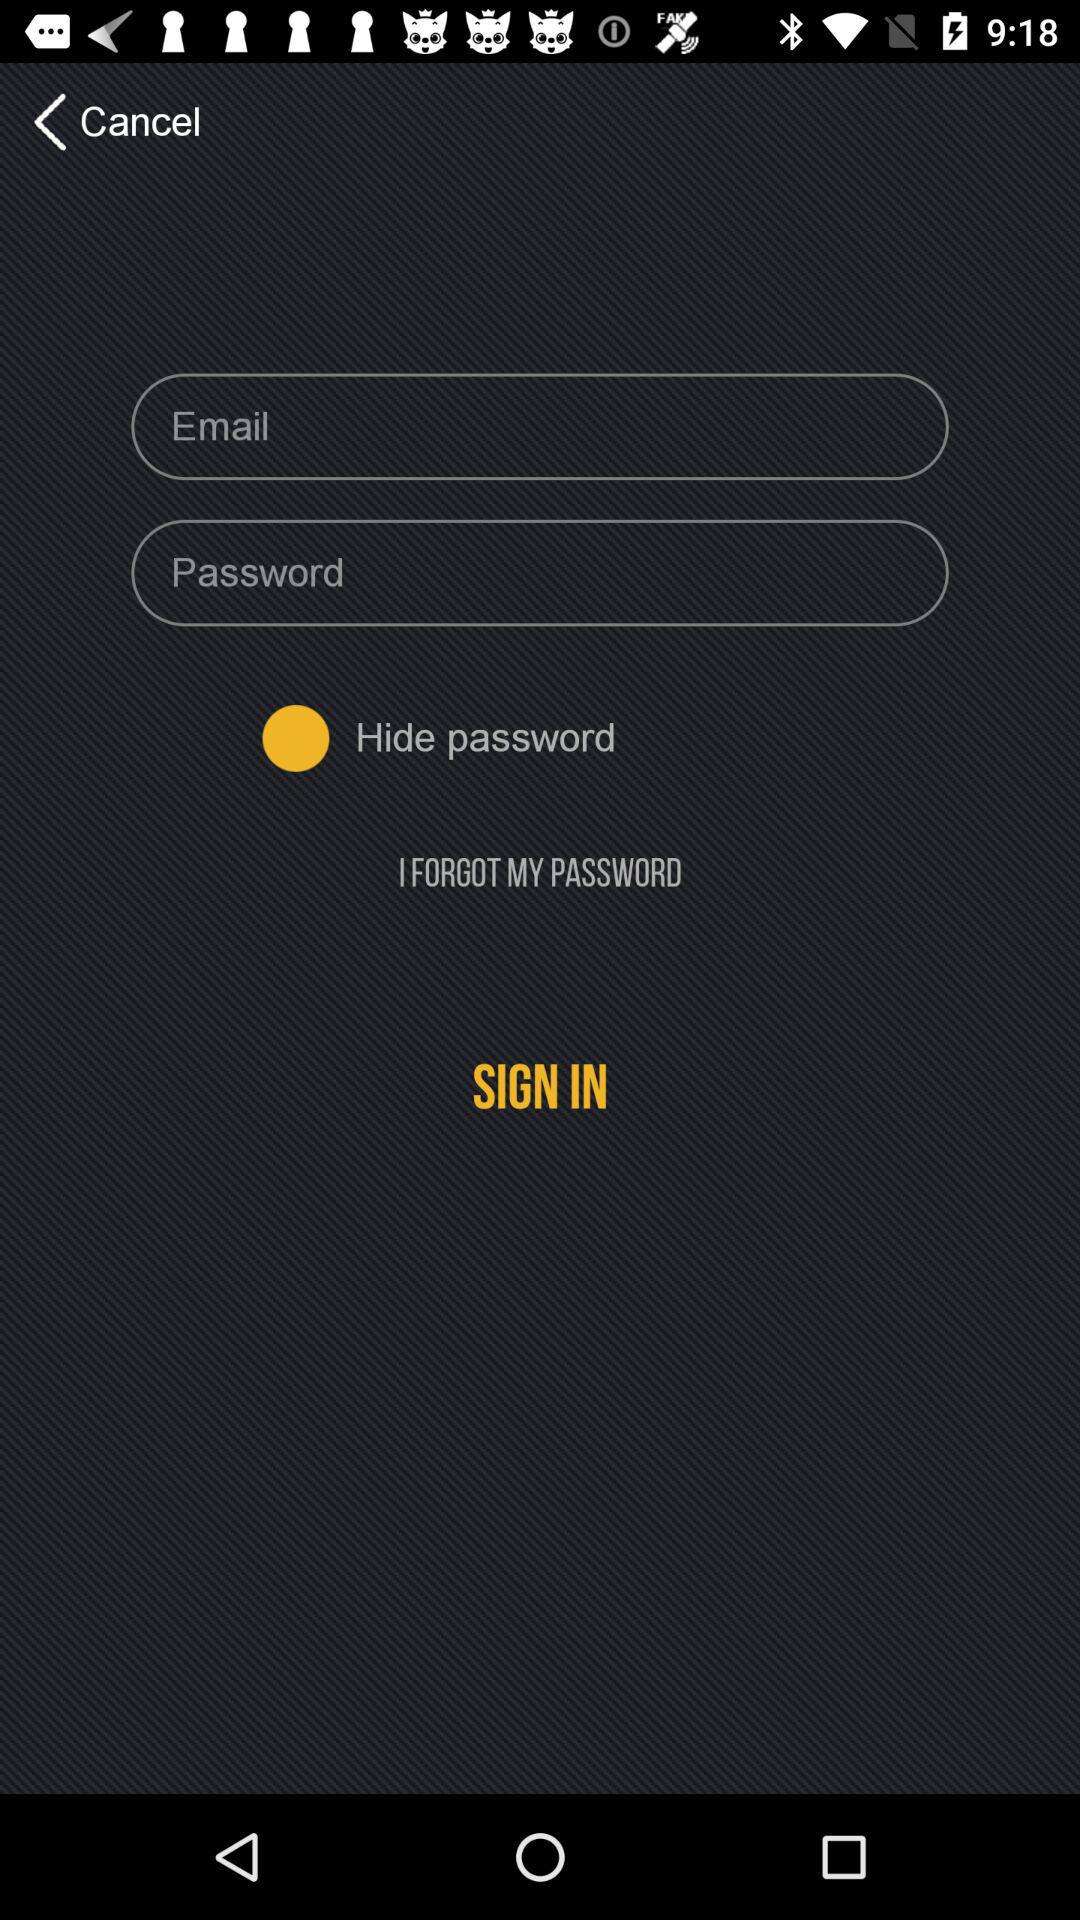Is "Hide password" checked or not checked? "Hide password" is not checked. 